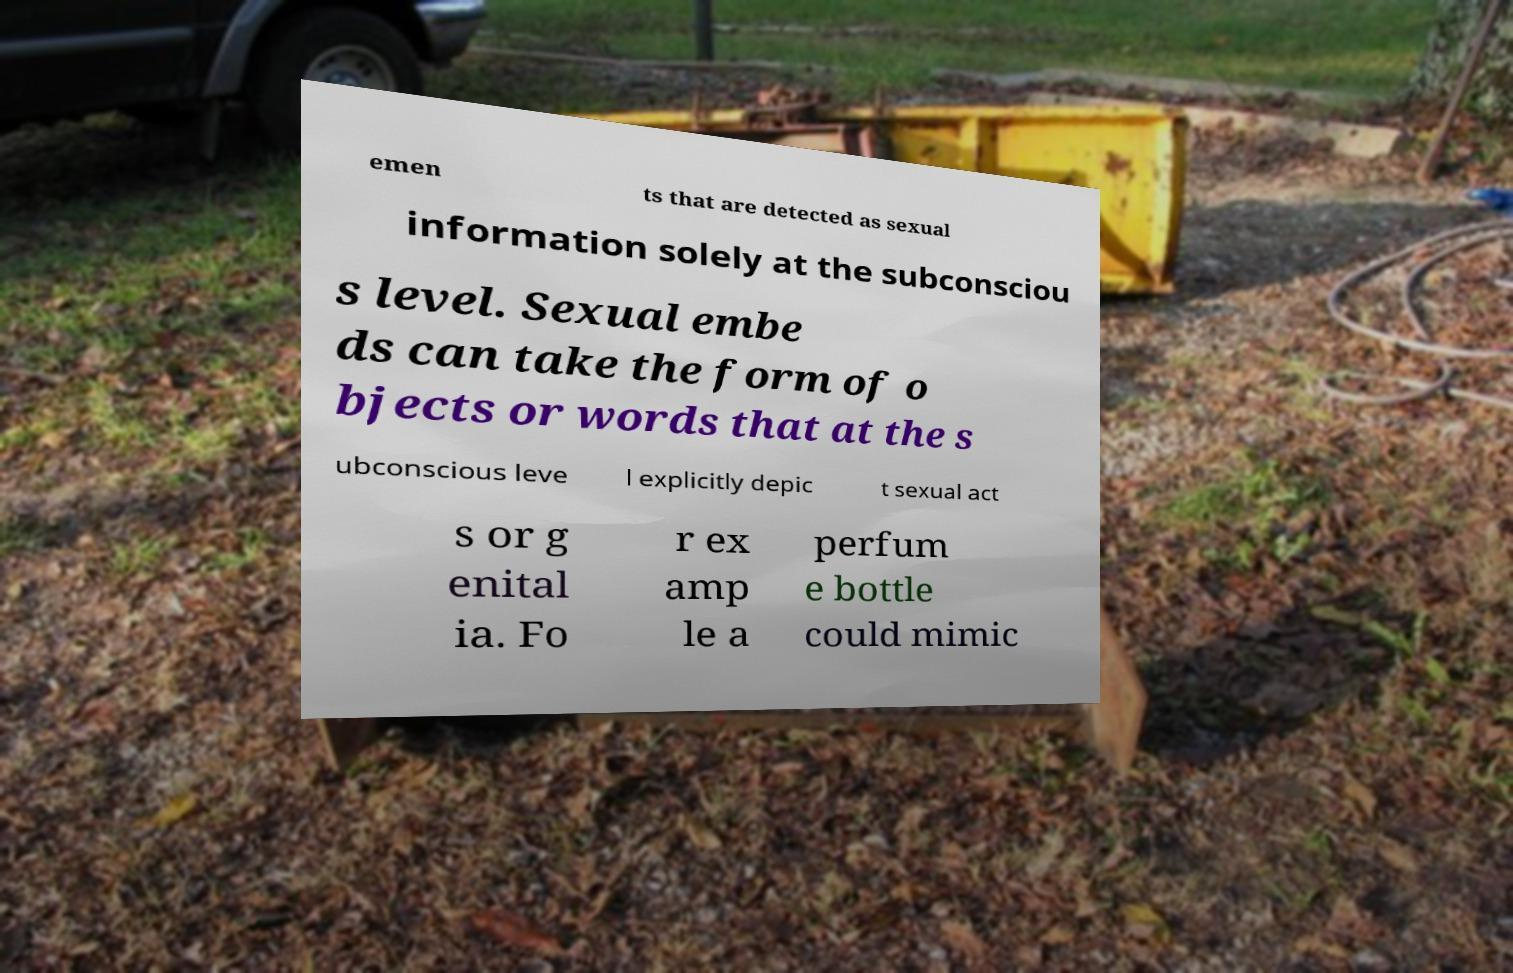There's text embedded in this image that I need extracted. Can you transcribe it verbatim? emen ts that are detected as sexual information solely at the subconsciou s level. Sexual embe ds can take the form of o bjects or words that at the s ubconscious leve l explicitly depic t sexual act s or g enital ia. Fo r ex amp le a perfum e bottle could mimic 